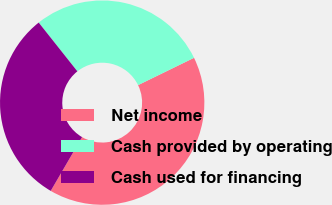Convert chart. <chart><loc_0><loc_0><loc_500><loc_500><pie_chart><fcel>Net income<fcel>Cash provided by operating<fcel>Cash used for financing<nl><fcel>40.63%<fcel>28.45%<fcel>30.93%<nl></chart> 